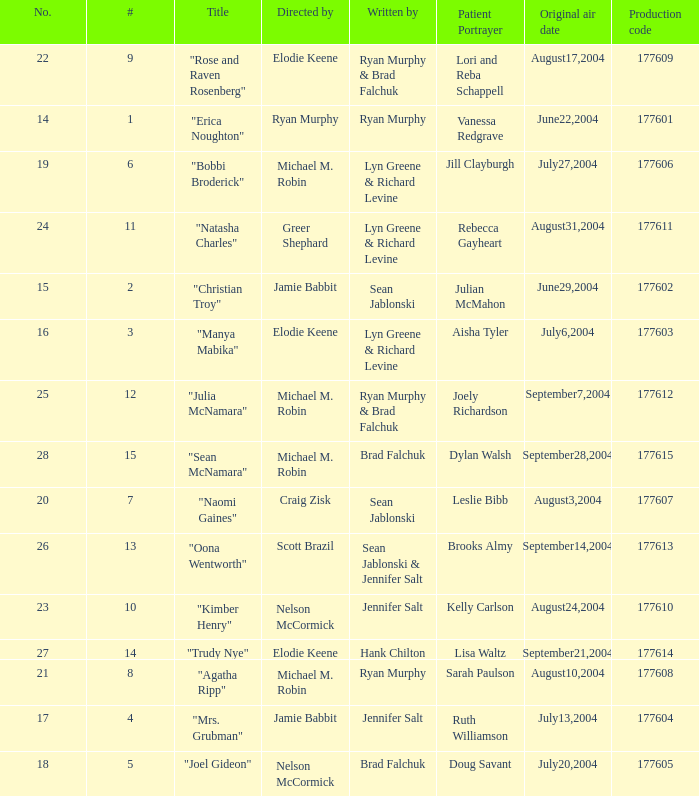What numbered episode is titled "naomi gaines"? 20.0. 